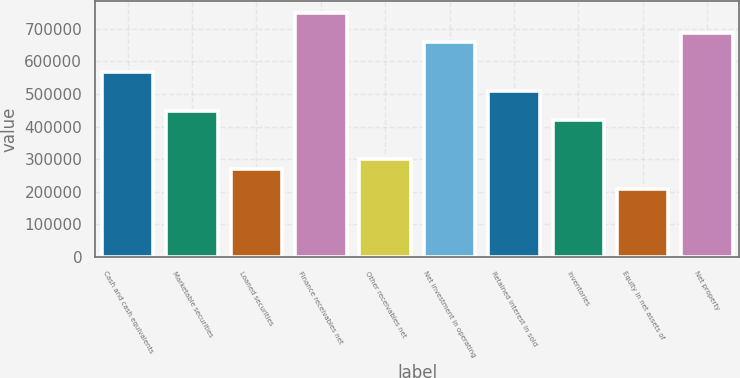Convert chart. <chart><loc_0><loc_0><loc_500><loc_500><bar_chart><fcel>Cash and cash equivalents<fcel>Marketable securities<fcel>Loaned securities<fcel>Finance receivables net<fcel>Other receivables net<fcel>Net investment in operating<fcel>Retained interest in sold<fcel>Inventories<fcel>Equity in net assets of<fcel>Net property<nl><fcel>568853<fcel>449095<fcel>269457<fcel>748491<fcel>299397<fcel>658672<fcel>508974<fcel>419155<fcel>209578<fcel>688612<nl></chart> 